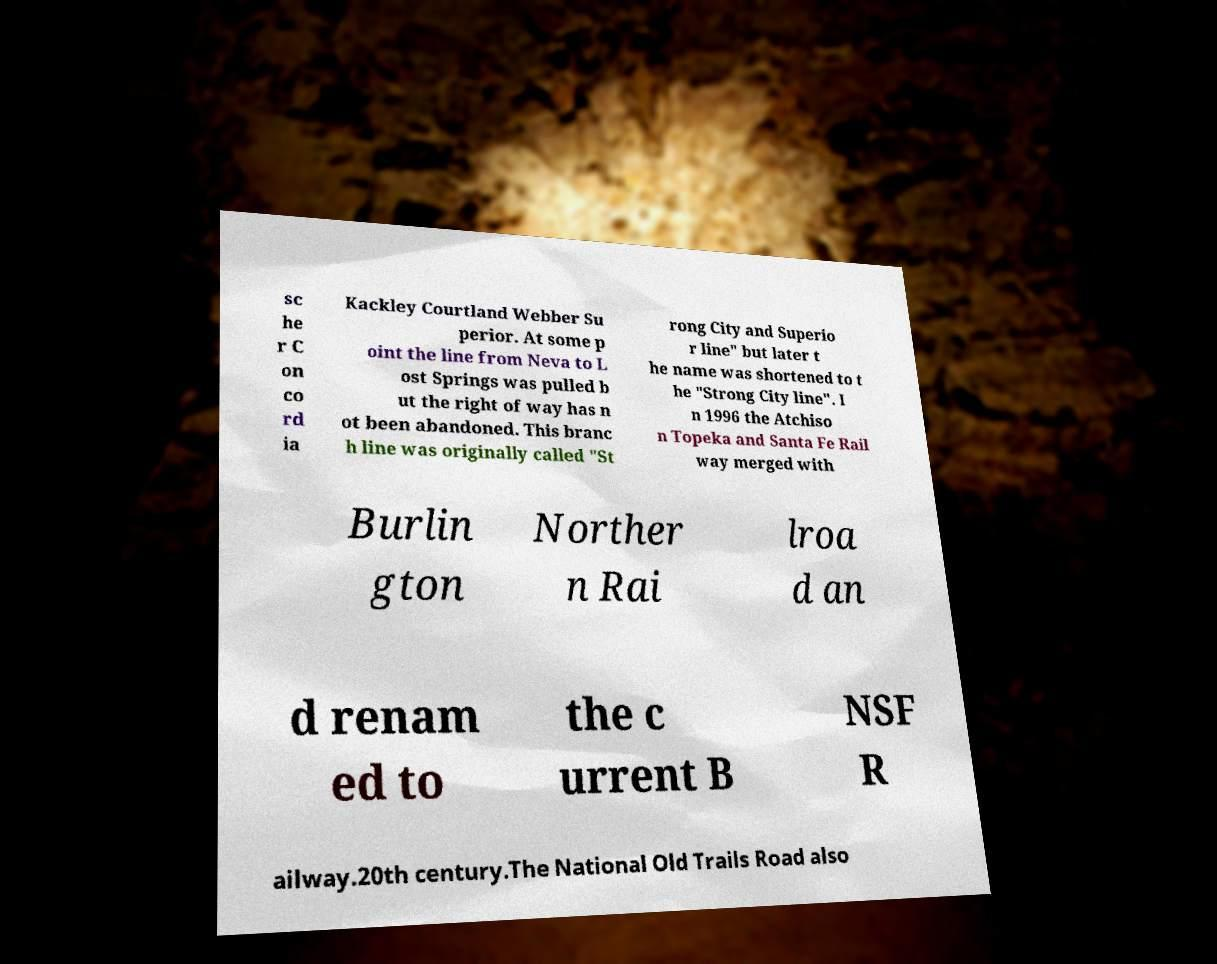There's text embedded in this image that I need extracted. Can you transcribe it verbatim? sc he r C on co rd ia Kackley Courtland Webber Su perior. At some p oint the line from Neva to L ost Springs was pulled b ut the right of way has n ot been abandoned. This branc h line was originally called "St rong City and Superio r line" but later t he name was shortened to t he "Strong City line". I n 1996 the Atchiso n Topeka and Santa Fe Rail way merged with Burlin gton Norther n Rai lroa d an d renam ed to the c urrent B NSF R ailway.20th century.The National Old Trails Road also 